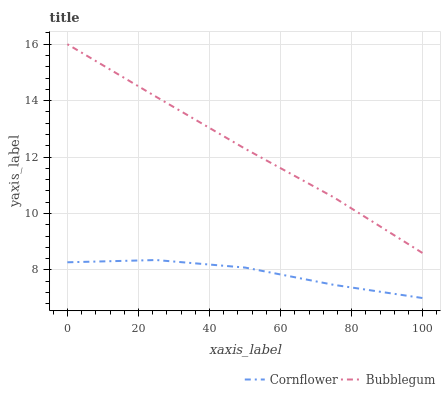Does Cornflower have the minimum area under the curve?
Answer yes or no. Yes. Does Bubblegum have the maximum area under the curve?
Answer yes or no. Yes. Does Bubblegum have the minimum area under the curve?
Answer yes or no. No. Is Bubblegum the smoothest?
Answer yes or no. Yes. Is Cornflower the roughest?
Answer yes or no. Yes. Is Bubblegum the roughest?
Answer yes or no. No. Does Cornflower have the lowest value?
Answer yes or no. Yes. Does Bubblegum have the lowest value?
Answer yes or no. No. Does Bubblegum have the highest value?
Answer yes or no. Yes. Is Cornflower less than Bubblegum?
Answer yes or no. Yes. Is Bubblegum greater than Cornflower?
Answer yes or no. Yes. Does Cornflower intersect Bubblegum?
Answer yes or no. No. 